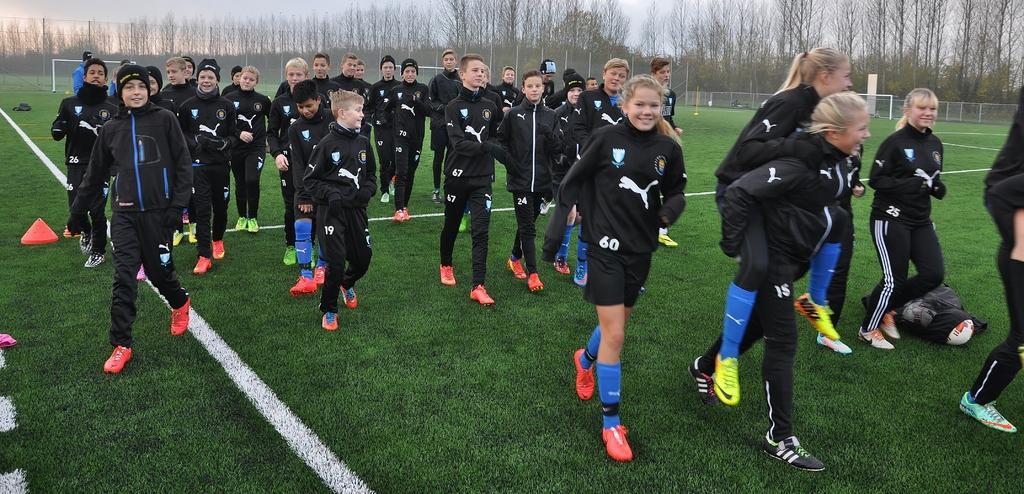Could you give a brief overview of what you see in this image? In the background we can see the sky, trees, fence. In this picture we can see poles, grass and few objects. We can see people wearing jackets and shoes. 